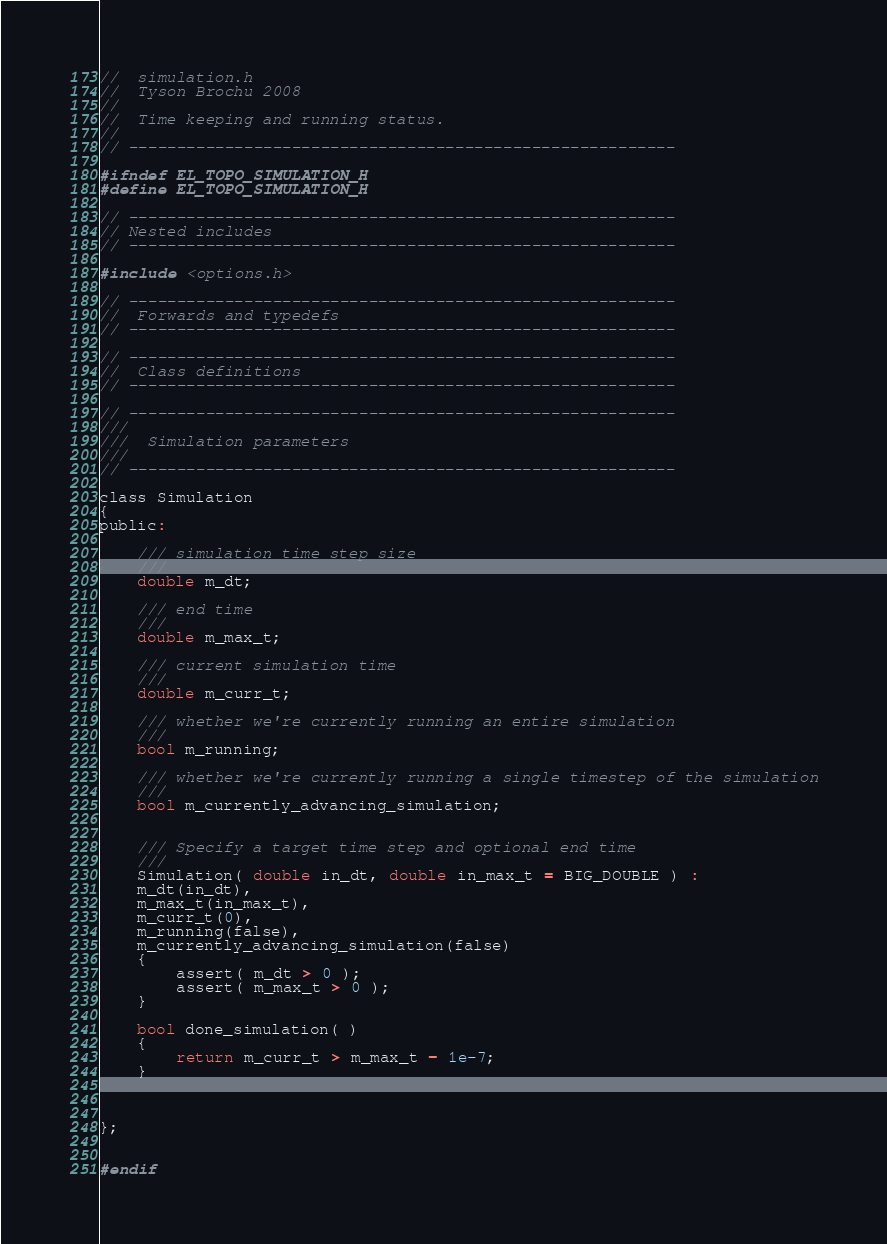<code> <loc_0><loc_0><loc_500><loc_500><_C_>//  simulation.h
//  Tyson Brochu 2008
//
//  Time keeping and running status.
//
// ---------------------------------------------------------

#ifndef EL_TOPO_SIMULATION_H
#define EL_TOPO_SIMULATION_H

// ---------------------------------------------------------
// Nested includes
// ---------------------------------------------------------

#include <options.h>

// ---------------------------------------------------------
//  Forwards and typedefs
// ---------------------------------------------------------

// ---------------------------------------------------------
//  Class definitions
// ---------------------------------------------------------

// ---------------------------------------------------------
///
///  Simulation parameters
///
// ---------------------------------------------------------

class Simulation
{
public:
    
    /// simulation time step size
    ///
    double m_dt;
    
    /// end time
    ///
    double m_max_t;
    
    /// current simulation time
    ///
    double m_curr_t;
    
    /// whether we're currently running an entire simulation
    ///
    bool m_running;
    
    /// whether we're currently running a single timestep of the simulation
    ///
    bool m_currently_advancing_simulation;
    
    
    /// Specify a target time step and optional end time
    ///
    Simulation( double in_dt, double in_max_t = BIG_DOUBLE ) :
    m_dt(in_dt),
    m_max_t(in_max_t),
    m_curr_t(0),
    m_running(false),
    m_currently_advancing_simulation(false)
    {
        assert( m_dt > 0 );
        assert( m_max_t > 0 );
    }
    
    bool done_simulation( )
    {
        return m_curr_t > m_max_t - 1e-7;
    }
    
    
    
};


#endif



</code> 